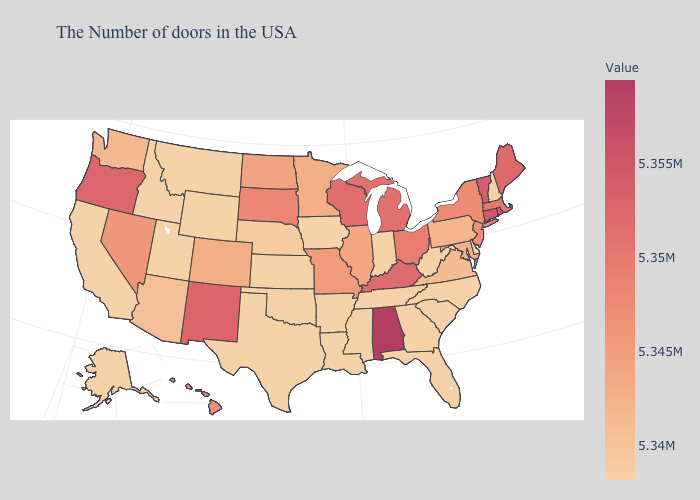Which states hav the highest value in the Northeast?
Write a very short answer. Connecticut. Does South Dakota have a higher value than Florida?
Answer briefly. Yes. Does Wyoming have the lowest value in the USA?
Short answer required. Yes. Which states have the lowest value in the Northeast?
Write a very short answer. New Hampshire. Does Mississippi have the lowest value in the USA?
Be succinct. Yes. Among the states that border Missouri , which have the lowest value?
Give a very brief answer. Tennessee, Arkansas, Iowa, Kansas, Oklahoma. Does Colorado have the lowest value in the USA?
Give a very brief answer. No. Among the states that border Tennessee , which have the highest value?
Answer briefly. Alabama. Does Connecticut have a lower value than Alabama?
Be succinct. Yes. 